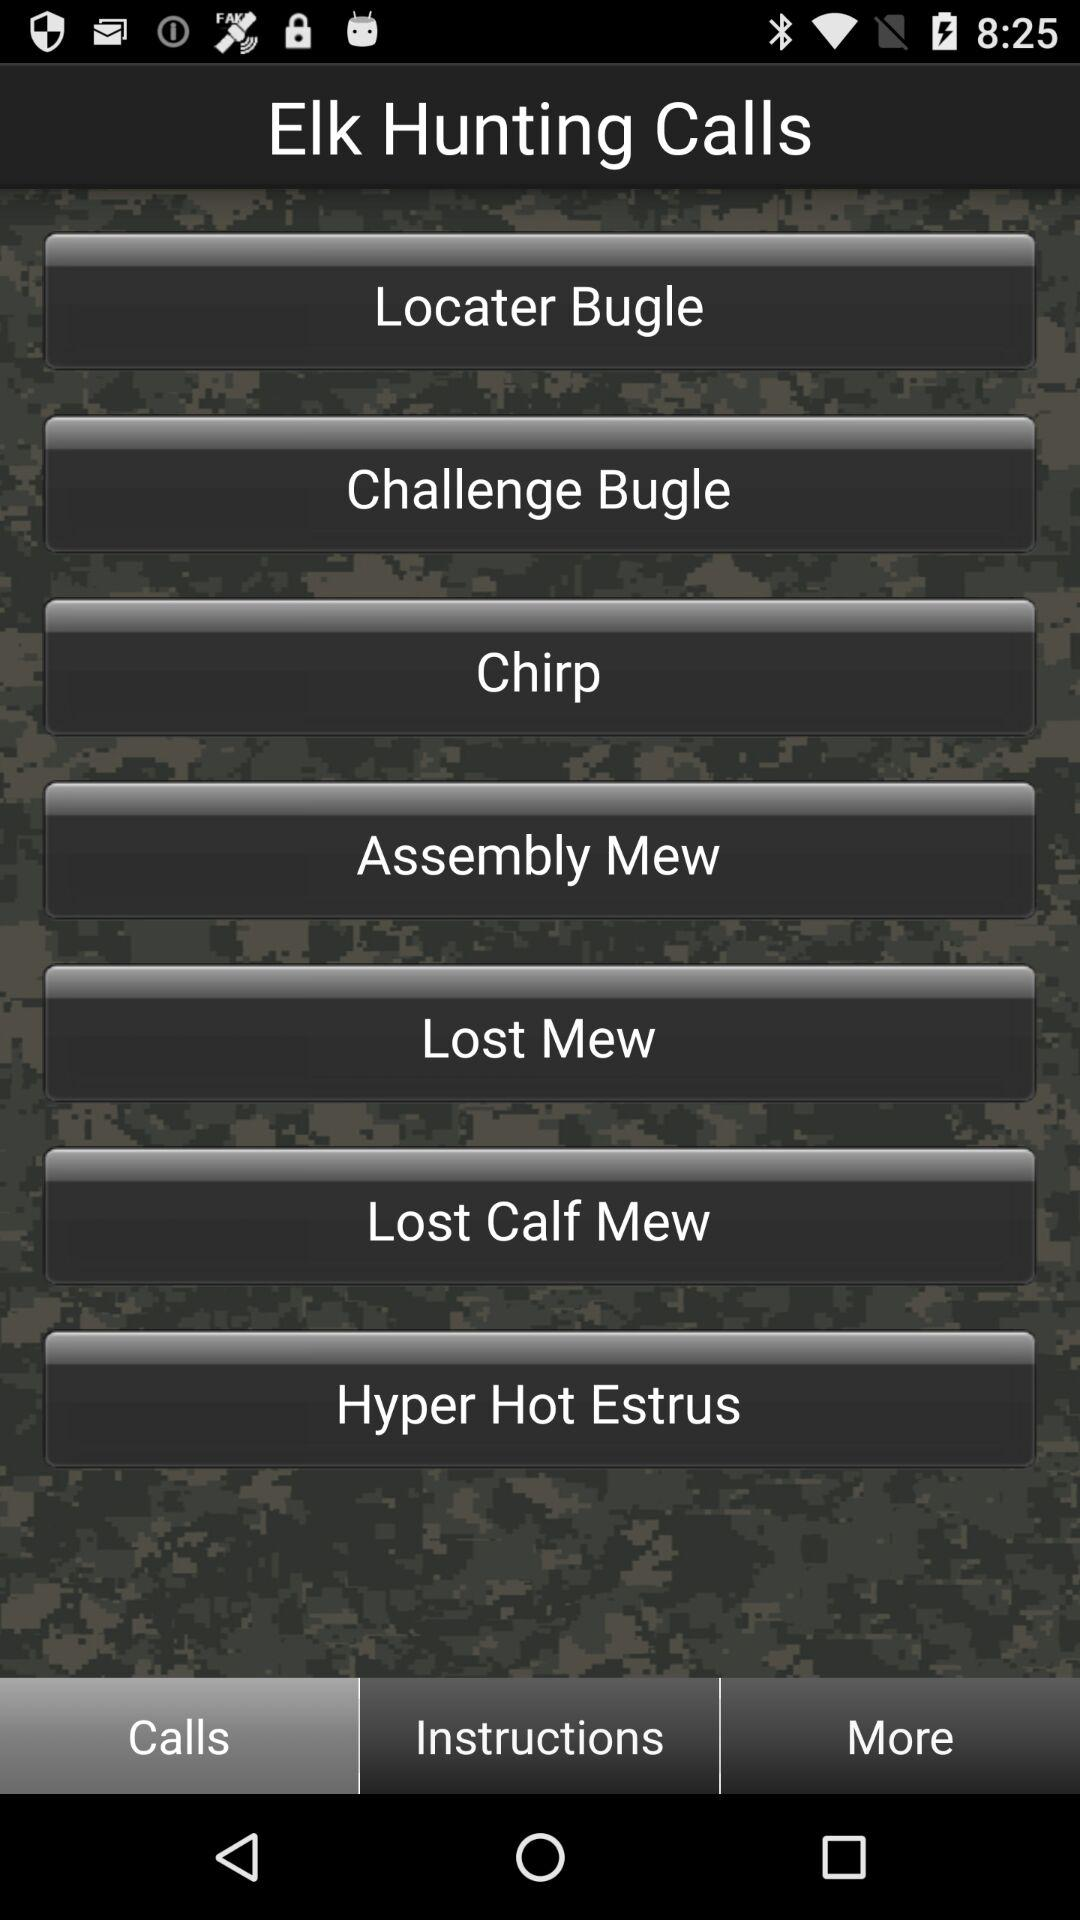Which tab is currently active at the bottom? The tab currently active is "Calls". 